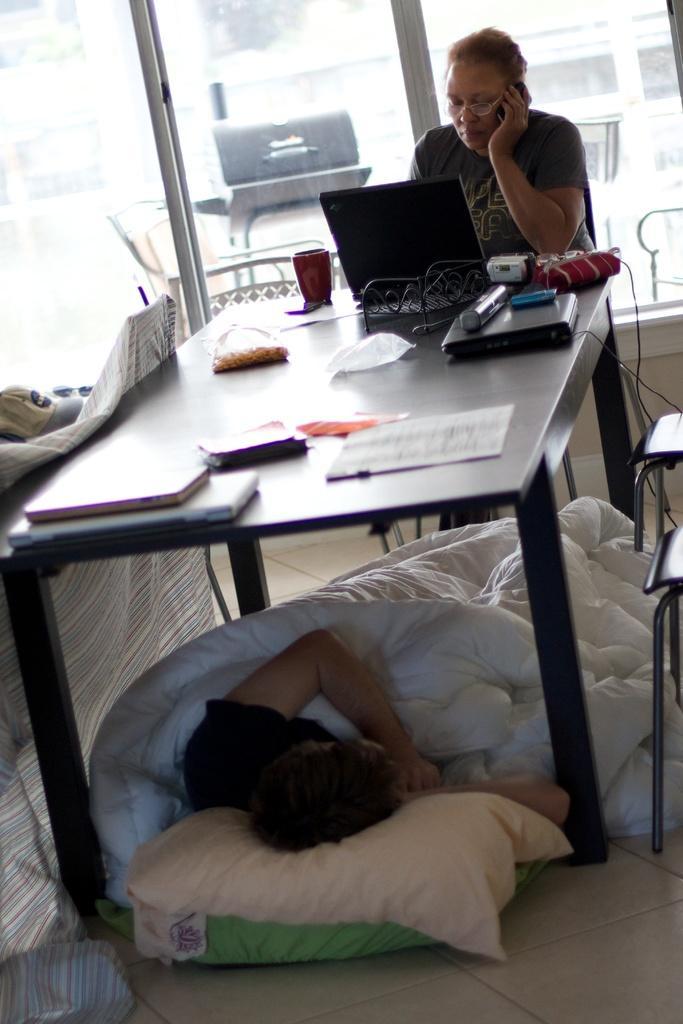Can you describe this image briefly? In this image I see a woman who is sitting on chair and there is a table in front of her on which there is a laptop, papers, cup and other few things. I can also see there is a man who is under the table and he is sleeping and I see the chairs over here. In the background I see the glass. 